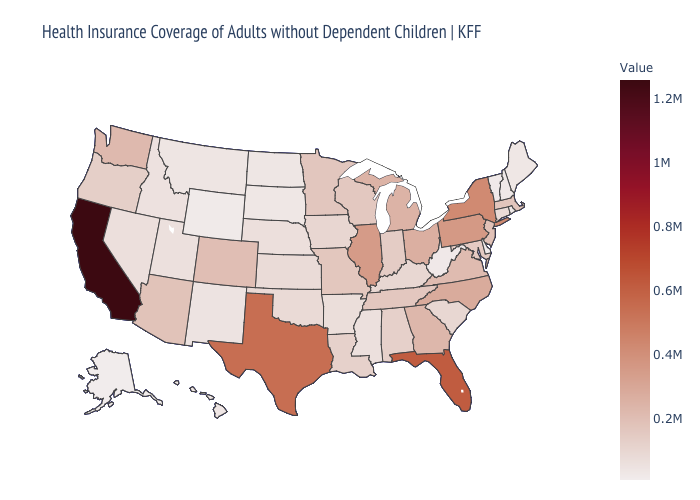Does Alaska have the lowest value in the USA?
Give a very brief answer. Yes. Does the map have missing data?
Be succinct. No. Does South Carolina have the highest value in the USA?
Give a very brief answer. No. Does Nebraska have the highest value in the MidWest?
Quick response, please. No. Which states have the lowest value in the USA?
Short answer required. Alaska. 